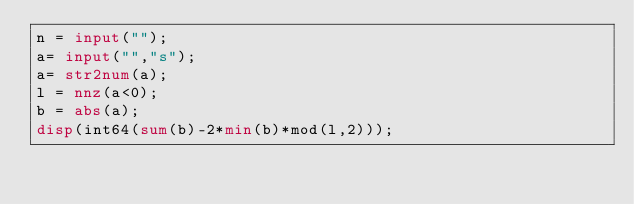Convert code to text. <code><loc_0><loc_0><loc_500><loc_500><_Octave_>n = input("");
a= input("","s");
a= str2num(a);
l = nnz(a<0);
b = abs(a);
disp(int64(sum(b)-2*min(b)*mod(l,2)));
</code> 